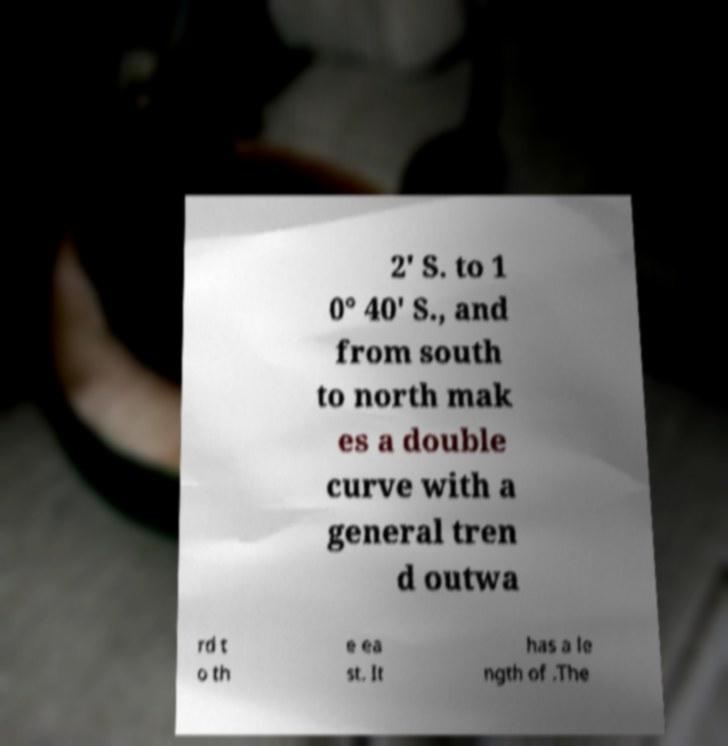Could you extract and type out the text from this image? 2′ S. to 1 0° 40′ S., and from south to north mak es a double curve with a general tren d outwa rd t o th e ea st. It has a le ngth of .The 